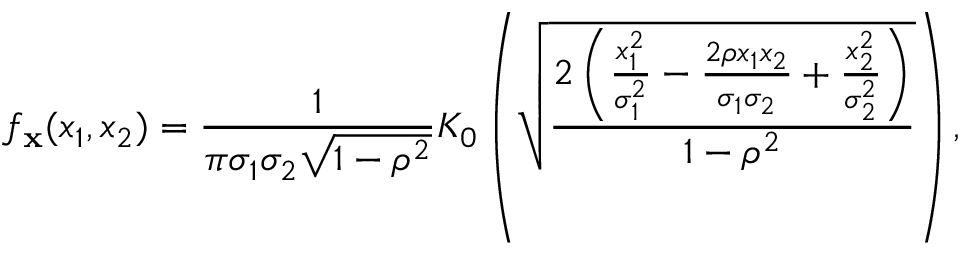<formula> <loc_0><loc_0><loc_500><loc_500>f _ { x } ( x _ { 1 } , x _ { 2 } ) = { \frac { 1 } { \pi \sigma _ { 1 } \sigma _ { 2 } { \sqrt { 1 - \rho ^ { 2 } } } } } K _ { 0 } \left ( { \sqrt { \frac { 2 \left ( { \frac { x _ { 1 } ^ { 2 } } { \sigma _ { 1 } ^ { 2 } } } - { \frac { 2 \rho x _ { 1 } x _ { 2 } } { \sigma _ { 1 } \sigma _ { 2 } } } + { \frac { x _ { 2 } ^ { 2 } } { \sigma _ { 2 } ^ { 2 } } } \right ) } { 1 - \rho ^ { 2 } } } } \right ) ,</formula> 